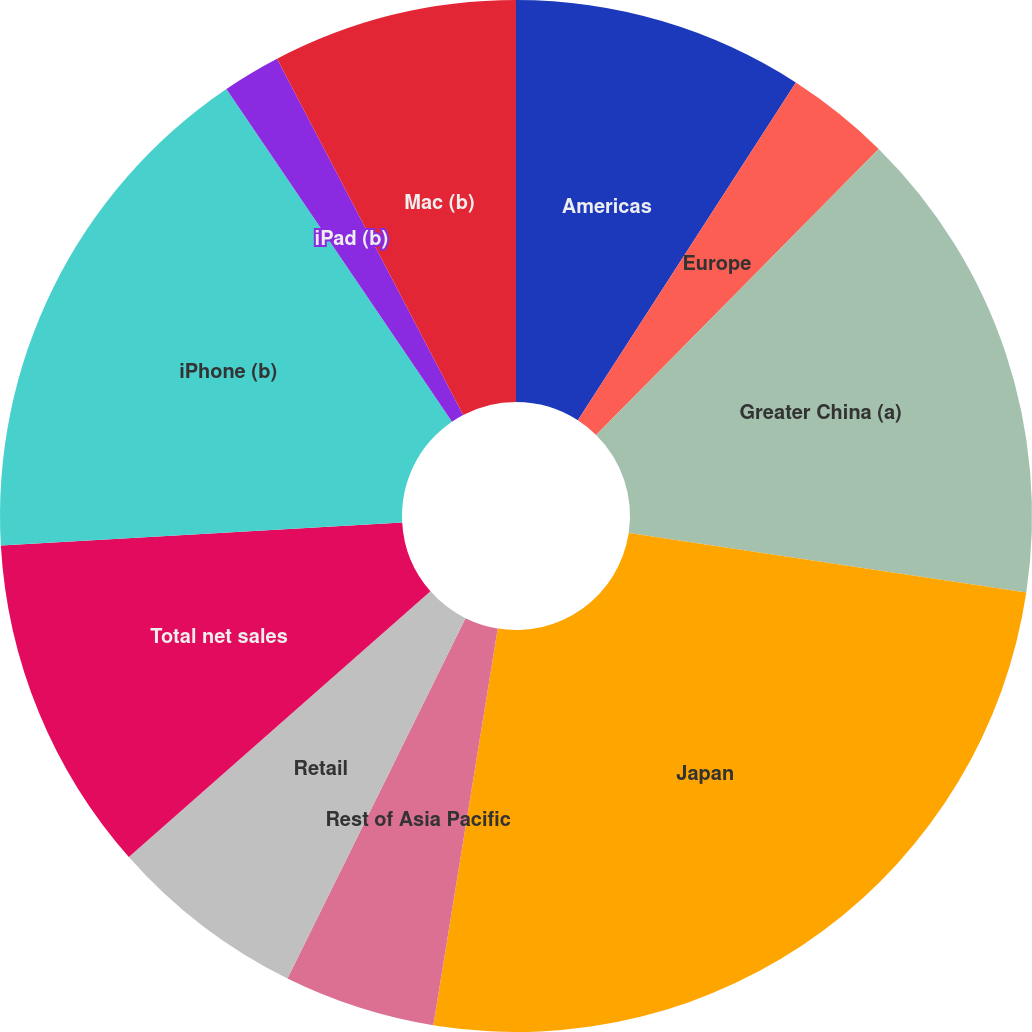<chart> <loc_0><loc_0><loc_500><loc_500><pie_chart><fcel>Americas<fcel>Europe<fcel>Greater China (a)<fcel>Japan<fcel>Rest of Asia Pacific<fcel>Retail<fcel>Total net sales<fcel>iPhone (b)<fcel>iPad (b)<fcel>Mac (b)<nl><fcel>9.12%<fcel>3.28%<fcel>14.96%<fcel>25.18%<fcel>4.74%<fcel>6.2%<fcel>10.58%<fcel>16.42%<fcel>1.82%<fcel>7.66%<nl></chart> 